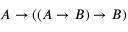Convert formula to latex. <formula><loc_0><loc_0><loc_500><loc_500>A \to ( ( A \to B ) \to B )</formula> 